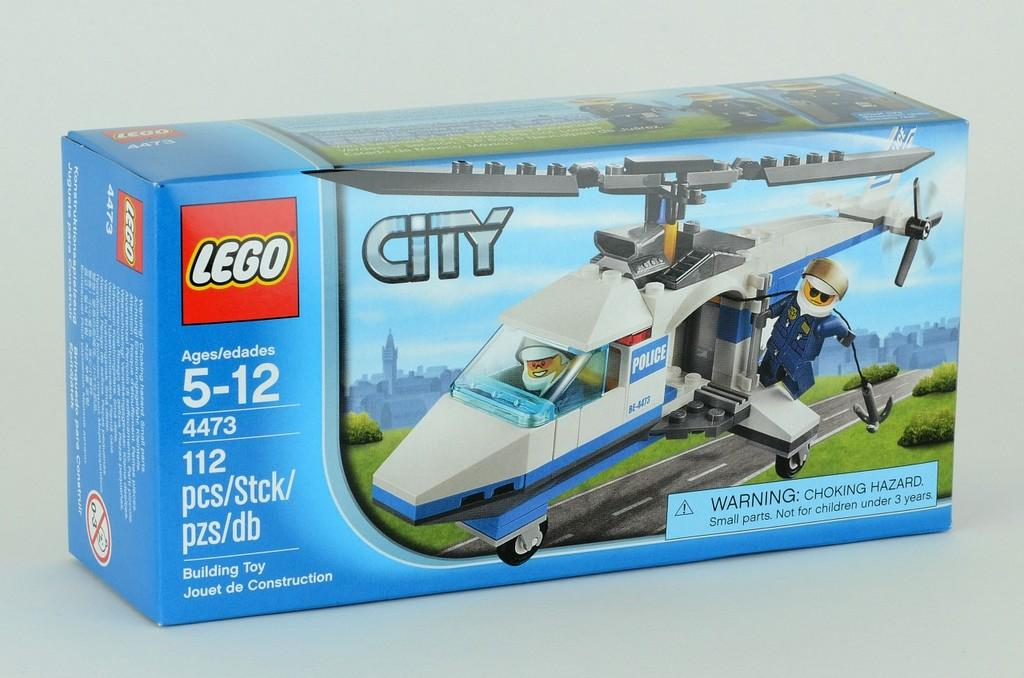<image>
Offer a succinct explanation of the picture presented. A blue Lego box had a City Helicopter inside ready to be built 